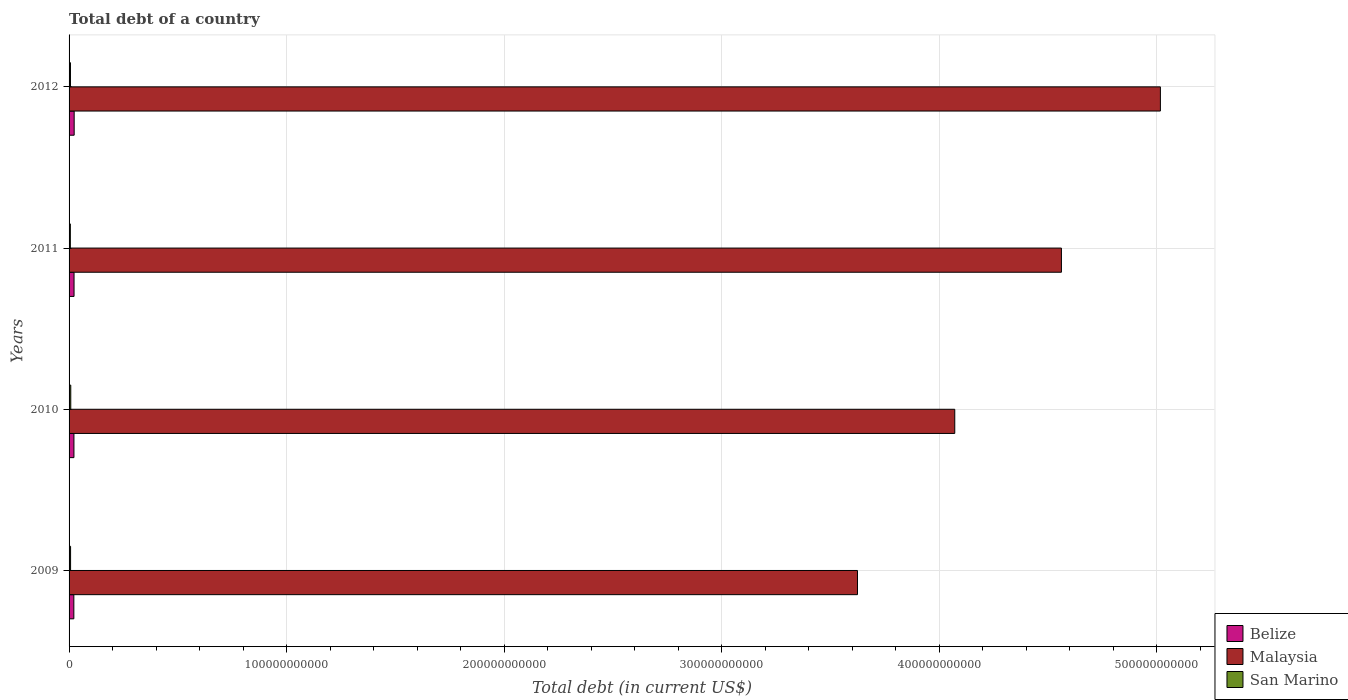How many different coloured bars are there?
Keep it short and to the point. 3. Are the number of bars per tick equal to the number of legend labels?
Make the answer very short. Yes. What is the label of the 3rd group of bars from the top?
Keep it short and to the point. 2010. In how many cases, is the number of bars for a given year not equal to the number of legend labels?
Offer a very short reply. 0. What is the debt in Belize in 2009?
Your response must be concise. 2.19e+09. Across all years, what is the maximum debt in Malaysia?
Your response must be concise. 5.02e+11. Across all years, what is the minimum debt in Malaysia?
Keep it short and to the point. 3.62e+11. In which year was the debt in Malaysia maximum?
Your response must be concise. 2012. What is the total debt in Malaysia in the graph?
Your response must be concise. 1.73e+12. What is the difference between the debt in San Marino in 2009 and that in 2011?
Offer a terse response. 1.06e+08. What is the difference between the debt in San Marino in 2010 and the debt in Belize in 2009?
Your answer should be very brief. -1.41e+09. What is the average debt in Malaysia per year?
Provide a short and direct response. 4.32e+11. In the year 2012, what is the difference between the debt in Malaysia and debt in San Marino?
Keep it short and to the point. 5.01e+11. In how many years, is the debt in Belize greater than 200000000000 US$?
Your answer should be very brief. 0. What is the ratio of the debt in San Marino in 2009 to that in 2010?
Keep it short and to the point. 0.88. Is the debt in Malaysia in 2011 less than that in 2012?
Provide a short and direct response. Yes. What is the difference between the highest and the second highest debt in Malaysia?
Your answer should be compact. 4.55e+1. What is the difference between the highest and the lowest debt in San Marino?
Provide a short and direct response. 1.96e+08. What does the 3rd bar from the top in 2011 represents?
Your response must be concise. Belize. What does the 1st bar from the bottom in 2011 represents?
Offer a terse response. Belize. Is it the case that in every year, the sum of the debt in Belize and debt in Malaysia is greater than the debt in San Marino?
Offer a very short reply. Yes. How many bars are there?
Make the answer very short. 12. Are all the bars in the graph horizontal?
Keep it short and to the point. Yes. What is the difference between two consecutive major ticks on the X-axis?
Keep it short and to the point. 1.00e+11. Does the graph contain grids?
Offer a terse response. Yes. Where does the legend appear in the graph?
Offer a terse response. Bottom right. How are the legend labels stacked?
Offer a terse response. Vertical. What is the title of the graph?
Ensure brevity in your answer.  Total debt of a country. Does "Tanzania" appear as one of the legend labels in the graph?
Your response must be concise. No. What is the label or title of the X-axis?
Keep it short and to the point. Total debt (in current US$). What is the label or title of the Y-axis?
Give a very brief answer. Years. What is the Total debt (in current US$) of Belize in 2009?
Make the answer very short. 2.19e+09. What is the Total debt (in current US$) of Malaysia in 2009?
Provide a short and direct response. 3.62e+11. What is the Total debt (in current US$) in San Marino in 2009?
Your response must be concise. 6.90e+08. What is the Total debt (in current US$) in Belize in 2010?
Make the answer very short. 2.24e+09. What is the Total debt (in current US$) in Malaysia in 2010?
Your response must be concise. 4.07e+11. What is the Total debt (in current US$) in San Marino in 2010?
Your answer should be compact. 7.80e+08. What is the Total debt (in current US$) in Belize in 2011?
Provide a short and direct response. 2.29e+09. What is the Total debt (in current US$) of Malaysia in 2011?
Give a very brief answer. 4.56e+11. What is the Total debt (in current US$) of San Marino in 2011?
Offer a terse response. 5.84e+08. What is the Total debt (in current US$) in Belize in 2012?
Provide a short and direct response. 2.34e+09. What is the Total debt (in current US$) in Malaysia in 2012?
Provide a short and direct response. 5.02e+11. What is the Total debt (in current US$) of San Marino in 2012?
Make the answer very short. 6.40e+08. Across all years, what is the maximum Total debt (in current US$) in Belize?
Ensure brevity in your answer.  2.34e+09. Across all years, what is the maximum Total debt (in current US$) in Malaysia?
Ensure brevity in your answer.  5.02e+11. Across all years, what is the maximum Total debt (in current US$) of San Marino?
Give a very brief answer. 7.80e+08. Across all years, what is the minimum Total debt (in current US$) of Belize?
Provide a succinct answer. 2.19e+09. Across all years, what is the minimum Total debt (in current US$) of Malaysia?
Offer a terse response. 3.62e+11. Across all years, what is the minimum Total debt (in current US$) of San Marino?
Keep it short and to the point. 5.84e+08. What is the total Total debt (in current US$) in Belize in the graph?
Give a very brief answer. 9.06e+09. What is the total Total debt (in current US$) of Malaysia in the graph?
Keep it short and to the point. 1.73e+12. What is the total Total debt (in current US$) of San Marino in the graph?
Give a very brief answer. 2.69e+09. What is the difference between the Total debt (in current US$) of Belize in 2009 and that in 2010?
Your answer should be very brief. -4.73e+07. What is the difference between the Total debt (in current US$) in Malaysia in 2009 and that in 2010?
Provide a succinct answer. -4.47e+1. What is the difference between the Total debt (in current US$) of San Marino in 2009 and that in 2010?
Your response must be concise. -9.03e+07. What is the difference between the Total debt (in current US$) in Belize in 2009 and that in 2011?
Provide a short and direct response. -9.35e+07. What is the difference between the Total debt (in current US$) of Malaysia in 2009 and that in 2011?
Offer a terse response. -9.37e+1. What is the difference between the Total debt (in current US$) in San Marino in 2009 and that in 2011?
Your response must be concise. 1.06e+08. What is the difference between the Total debt (in current US$) of Belize in 2009 and that in 2012?
Offer a terse response. -1.51e+08. What is the difference between the Total debt (in current US$) in Malaysia in 2009 and that in 2012?
Your answer should be very brief. -1.39e+11. What is the difference between the Total debt (in current US$) in San Marino in 2009 and that in 2012?
Give a very brief answer. 5.01e+07. What is the difference between the Total debt (in current US$) in Belize in 2010 and that in 2011?
Your response must be concise. -4.62e+07. What is the difference between the Total debt (in current US$) of Malaysia in 2010 and that in 2011?
Your answer should be very brief. -4.90e+1. What is the difference between the Total debt (in current US$) in San Marino in 2010 and that in 2011?
Make the answer very short. 1.96e+08. What is the difference between the Total debt (in current US$) of Belize in 2010 and that in 2012?
Give a very brief answer. -1.04e+08. What is the difference between the Total debt (in current US$) in Malaysia in 2010 and that in 2012?
Provide a succinct answer. -9.45e+1. What is the difference between the Total debt (in current US$) in San Marino in 2010 and that in 2012?
Provide a short and direct response. 1.40e+08. What is the difference between the Total debt (in current US$) in Belize in 2011 and that in 2012?
Provide a short and direct response. -5.79e+07. What is the difference between the Total debt (in current US$) in Malaysia in 2011 and that in 2012?
Provide a succinct answer. -4.55e+1. What is the difference between the Total debt (in current US$) of San Marino in 2011 and that in 2012?
Offer a terse response. -5.56e+07. What is the difference between the Total debt (in current US$) in Belize in 2009 and the Total debt (in current US$) in Malaysia in 2010?
Provide a short and direct response. -4.05e+11. What is the difference between the Total debt (in current US$) in Belize in 2009 and the Total debt (in current US$) in San Marino in 2010?
Your answer should be compact. 1.41e+09. What is the difference between the Total debt (in current US$) in Malaysia in 2009 and the Total debt (in current US$) in San Marino in 2010?
Give a very brief answer. 3.62e+11. What is the difference between the Total debt (in current US$) in Belize in 2009 and the Total debt (in current US$) in Malaysia in 2011?
Ensure brevity in your answer.  -4.54e+11. What is the difference between the Total debt (in current US$) of Belize in 2009 and the Total debt (in current US$) of San Marino in 2011?
Give a very brief answer. 1.61e+09. What is the difference between the Total debt (in current US$) of Malaysia in 2009 and the Total debt (in current US$) of San Marino in 2011?
Provide a short and direct response. 3.62e+11. What is the difference between the Total debt (in current US$) in Belize in 2009 and the Total debt (in current US$) in Malaysia in 2012?
Provide a short and direct response. -4.99e+11. What is the difference between the Total debt (in current US$) of Belize in 2009 and the Total debt (in current US$) of San Marino in 2012?
Provide a succinct answer. 1.55e+09. What is the difference between the Total debt (in current US$) of Malaysia in 2009 and the Total debt (in current US$) of San Marino in 2012?
Offer a terse response. 3.62e+11. What is the difference between the Total debt (in current US$) in Belize in 2010 and the Total debt (in current US$) in Malaysia in 2011?
Ensure brevity in your answer.  -4.54e+11. What is the difference between the Total debt (in current US$) in Belize in 2010 and the Total debt (in current US$) in San Marino in 2011?
Your answer should be compact. 1.66e+09. What is the difference between the Total debt (in current US$) in Malaysia in 2010 and the Total debt (in current US$) in San Marino in 2011?
Your response must be concise. 4.07e+11. What is the difference between the Total debt (in current US$) of Belize in 2010 and the Total debt (in current US$) of Malaysia in 2012?
Your response must be concise. -4.99e+11. What is the difference between the Total debt (in current US$) of Belize in 2010 and the Total debt (in current US$) of San Marino in 2012?
Offer a terse response. 1.60e+09. What is the difference between the Total debt (in current US$) in Malaysia in 2010 and the Total debt (in current US$) in San Marino in 2012?
Give a very brief answer. 4.06e+11. What is the difference between the Total debt (in current US$) of Belize in 2011 and the Total debt (in current US$) of Malaysia in 2012?
Provide a short and direct response. -4.99e+11. What is the difference between the Total debt (in current US$) of Belize in 2011 and the Total debt (in current US$) of San Marino in 2012?
Your answer should be compact. 1.65e+09. What is the difference between the Total debt (in current US$) in Malaysia in 2011 and the Total debt (in current US$) in San Marino in 2012?
Offer a very short reply. 4.55e+11. What is the average Total debt (in current US$) in Belize per year?
Offer a very short reply. 2.27e+09. What is the average Total debt (in current US$) in Malaysia per year?
Make the answer very short. 4.32e+11. What is the average Total debt (in current US$) in San Marino per year?
Your response must be concise. 6.73e+08. In the year 2009, what is the difference between the Total debt (in current US$) of Belize and Total debt (in current US$) of Malaysia?
Offer a very short reply. -3.60e+11. In the year 2009, what is the difference between the Total debt (in current US$) in Belize and Total debt (in current US$) in San Marino?
Provide a succinct answer. 1.50e+09. In the year 2009, what is the difference between the Total debt (in current US$) of Malaysia and Total debt (in current US$) of San Marino?
Your answer should be very brief. 3.62e+11. In the year 2010, what is the difference between the Total debt (in current US$) of Belize and Total debt (in current US$) of Malaysia?
Provide a short and direct response. -4.05e+11. In the year 2010, what is the difference between the Total debt (in current US$) of Belize and Total debt (in current US$) of San Marino?
Your response must be concise. 1.46e+09. In the year 2010, what is the difference between the Total debt (in current US$) in Malaysia and Total debt (in current US$) in San Marino?
Your answer should be compact. 4.06e+11. In the year 2011, what is the difference between the Total debt (in current US$) in Belize and Total debt (in current US$) in Malaysia?
Offer a very short reply. -4.54e+11. In the year 2011, what is the difference between the Total debt (in current US$) of Belize and Total debt (in current US$) of San Marino?
Give a very brief answer. 1.70e+09. In the year 2011, what is the difference between the Total debt (in current US$) in Malaysia and Total debt (in current US$) in San Marino?
Your response must be concise. 4.56e+11. In the year 2012, what is the difference between the Total debt (in current US$) in Belize and Total debt (in current US$) in Malaysia?
Your answer should be very brief. -4.99e+11. In the year 2012, what is the difference between the Total debt (in current US$) of Belize and Total debt (in current US$) of San Marino?
Keep it short and to the point. 1.70e+09. In the year 2012, what is the difference between the Total debt (in current US$) of Malaysia and Total debt (in current US$) of San Marino?
Offer a very short reply. 5.01e+11. What is the ratio of the Total debt (in current US$) in Belize in 2009 to that in 2010?
Ensure brevity in your answer.  0.98. What is the ratio of the Total debt (in current US$) of Malaysia in 2009 to that in 2010?
Provide a succinct answer. 0.89. What is the ratio of the Total debt (in current US$) of San Marino in 2009 to that in 2010?
Offer a terse response. 0.88. What is the ratio of the Total debt (in current US$) of Belize in 2009 to that in 2011?
Make the answer very short. 0.96. What is the ratio of the Total debt (in current US$) of Malaysia in 2009 to that in 2011?
Provide a succinct answer. 0.79. What is the ratio of the Total debt (in current US$) in San Marino in 2009 to that in 2011?
Your answer should be very brief. 1.18. What is the ratio of the Total debt (in current US$) in Belize in 2009 to that in 2012?
Your answer should be very brief. 0.94. What is the ratio of the Total debt (in current US$) in Malaysia in 2009 to that in 2012?
Your response must be concise. 0.72. What is the ratio of the Total debt (in current US$) of San Marino in 2009 to that in 2012?
Make the answer very short. 1.08. What is the ratio of the Total debt (in current US$) in Belize in 2010 to that in 2011?
Give a very brief answer. 0.98. What is the ratio of the Total debt (in current US$) in Malaysia in 2010 to that in 2011?
Give a very brief answer. 0.89. What is the ratio of the Total debt (in current US$) in San Marino in 2010 to that in 2011?
Your answer should be very brief. 1.34. What is the ratio of the Total debt (in current US$) of Belize in 2010 to that in 2012?
Give a very brief answer. 0.96. What is the ratio of the Total debt (in current US$) of Malaysia in 2010 to that in 2012?
Provide a succinct answer. 0.81. What is the ratio of the Total debt (in current US$) in San Marino in 2010 to that in 2012?
Provide a short and direct response. 1.22. What is the ratio of the Total debt (in current US$) of Belize in 2011 to that in 2012?
Make the answer very short. 0.98. What is the ratio of the Total debt (in current US$) of Malaysia in 2011 to that in 2012?
Your answer should be compact. 0.91. What is the ratio of the Total debt (in current US$) in San Marino in 2011 to that in 2012?
Provide a short and direct response. 0.91. What is the difference between the highest and the second highest Total debt (in current US$) of Belize?
Ensure brevity in your answer.  5.79e+07. What is the difference between the highest and the second highest Total debt (in current US$) in Malaysia?
Keep it short and to the point. 4.55e+1. What is the difference between the highest and the second highest Total debt (in current US$) of San Marino?
Make the answer very short. 9.03e+07. What is the difference between the highest and the lowest Total debt (in current US$) in Belize?
Offer a very short reply. 1.51e+08. What is the difference between the highest and the lowest Total debt (in current US$) of Malaysia?
Offer a terse response. 1.39e+11. What is the difference between the highest and the lowest Total debt (in current US$) of San Marino?
Provide a short and direct response. 1.96e+08. 